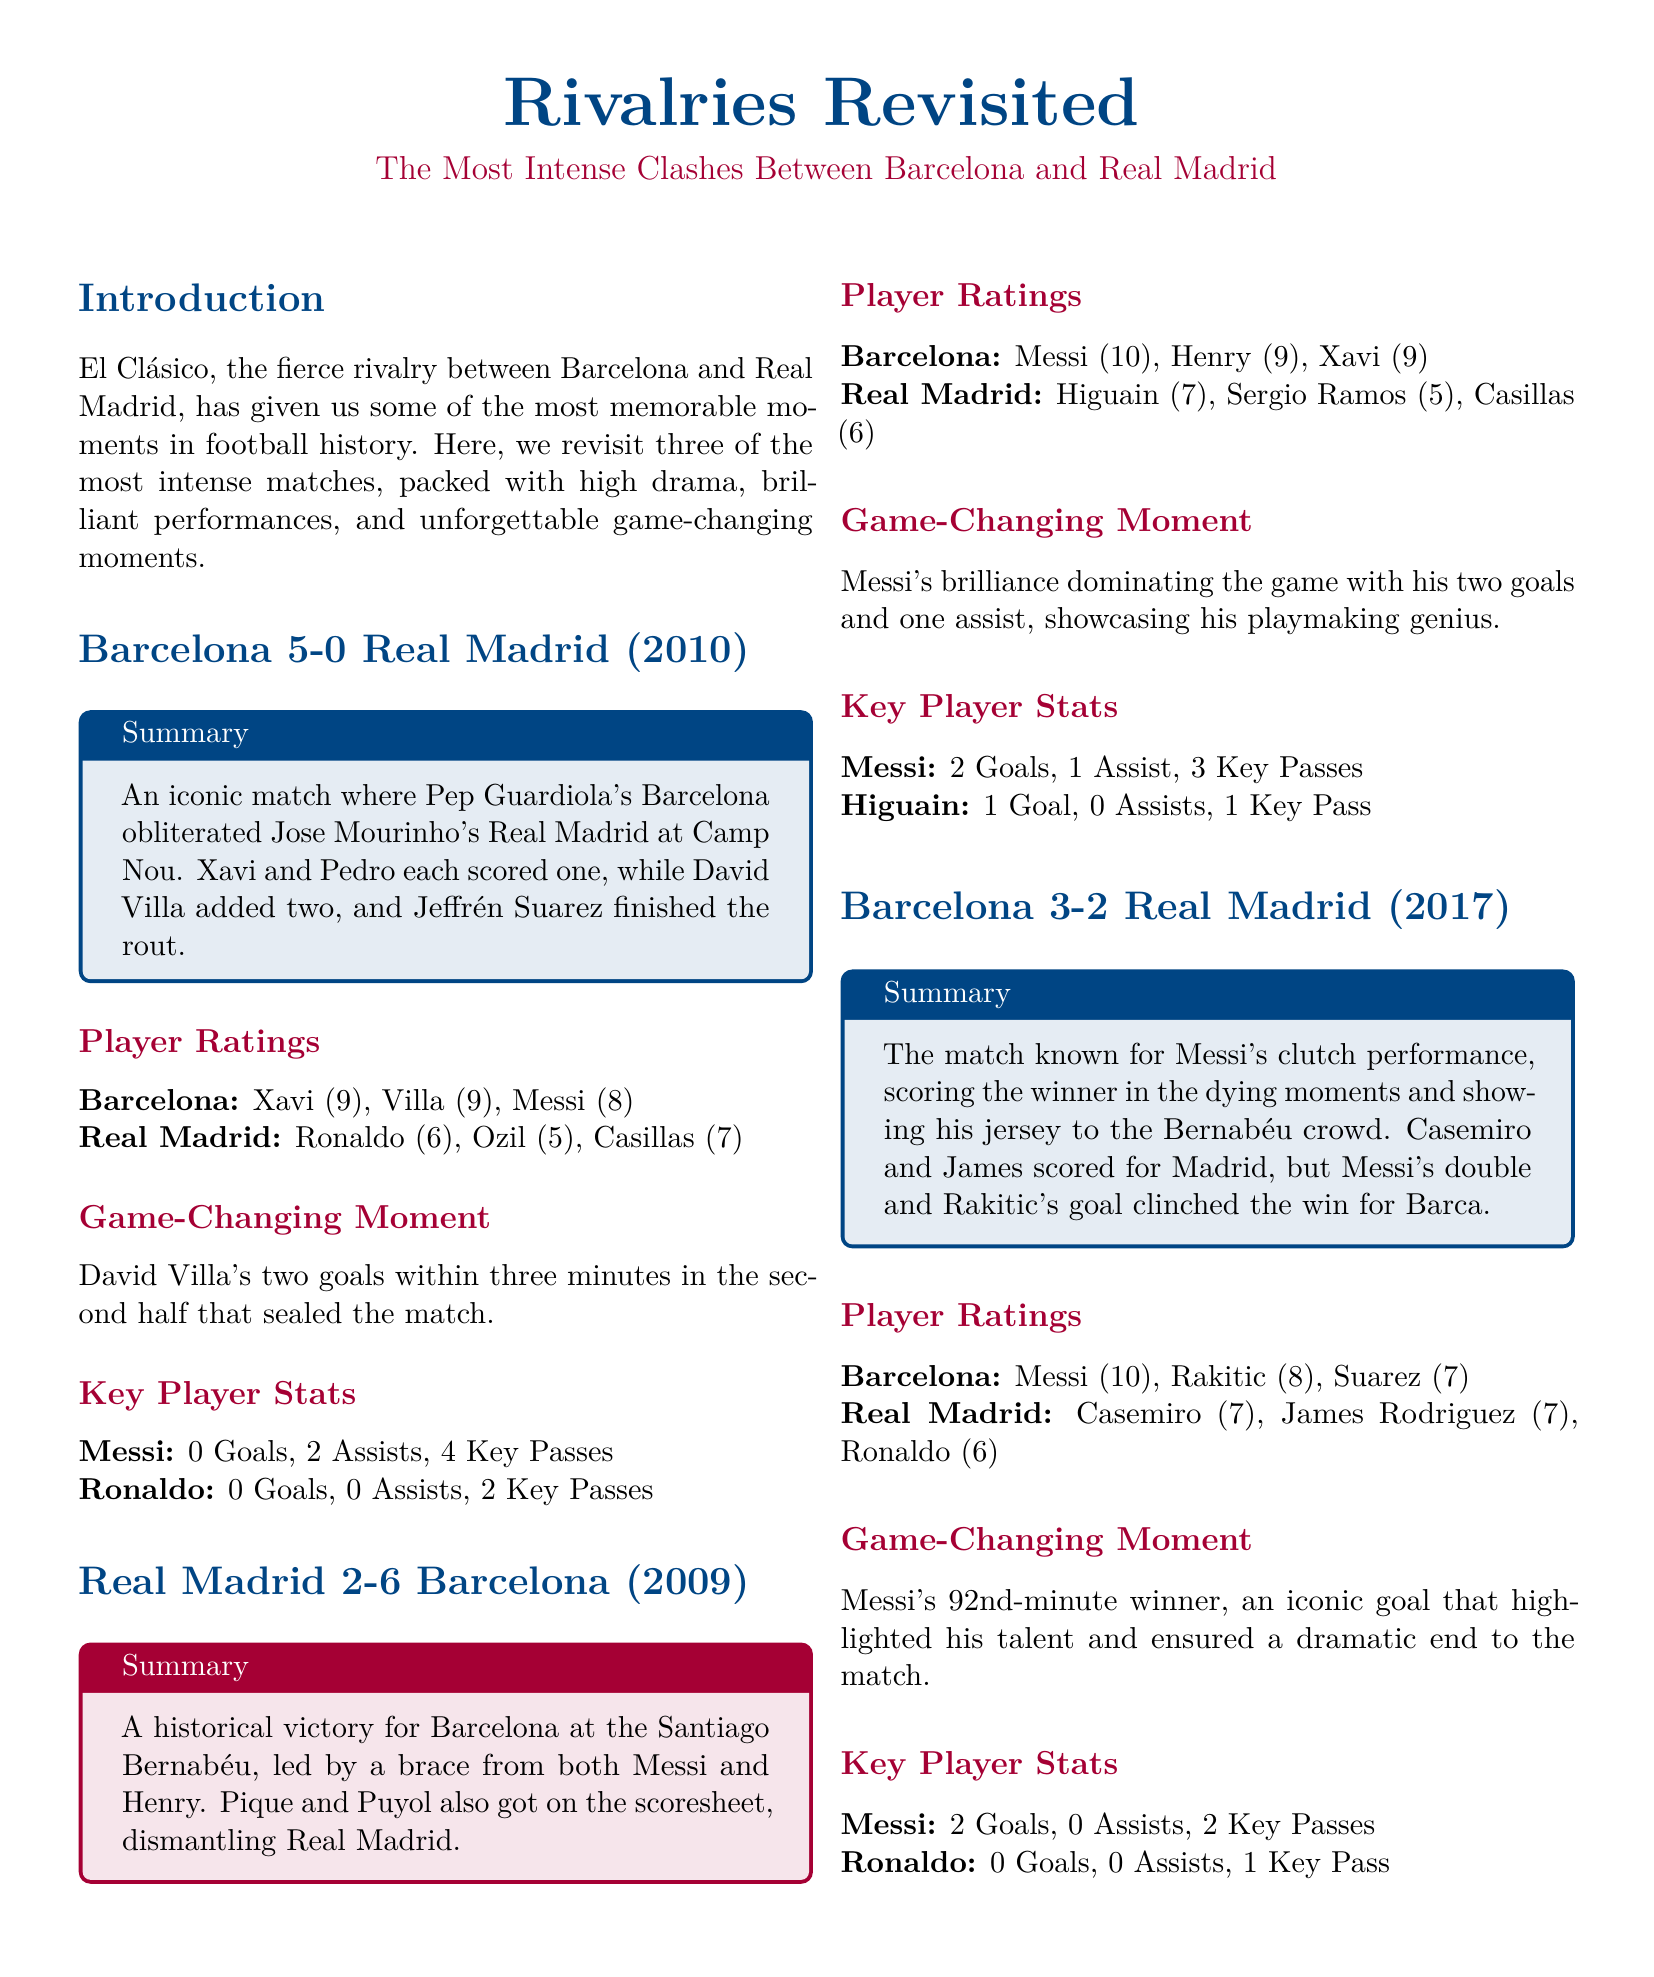What was the score of the 2010 match? The score of the 2010 match between Barcelona and Real Madrid was 5-0.
Answer: 5-0 Who scored the winning goal in the 2017 match? The winning goal in the 2017 match was scored by Messi in the 92nd minute.
Answer: Messi How many goals did Messi score in the 2009 match? Messi scored 2 goals in the 2009 match against Real Madrid.
Answer: 2 Goals What was the player rating of Xavi in the 2010 match? Xavi received a player rating of 9 in the 2010 match.
Answer: 9 What team did Pep Guardiola manage during the 2010 match? Pep Guardiola managed Barcelona in the 2010 match against Real Madrid.
Answer: Barcelona Which player had the highest rating in the 2009 match? The player with the highest rating in the 2009 match was Messi, with a rating of 10.
Answer: 10 What was the key player statistic for Ronaldo in the 2017 match? Ronaldo's key player statistic in the 2017 match was 0 Goals, 0 Assists.
Answer: 0 Goals, 0 Assists What notable moment occurred in the 2017 match? The notable moment in the 2017 match was Messi showing his jersey to the Bernabéu crowd.
Answer: Showing his jersey How many goals did David Villa score in the 2010 match? David Villa scored 2 goals in the 2010 match against Real Madrid.
Answer: 2 Goals 